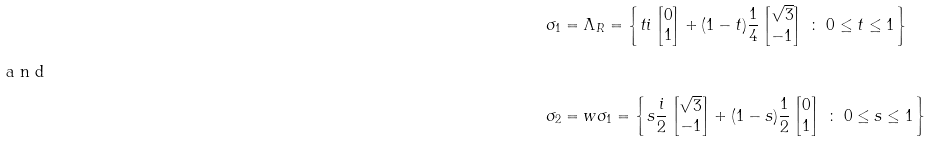Convert formula to latex. <formula><loc_0><loc_0><loc_500><loc_500>\sigma _ { 1 } & = \Lambda _ { R } = \left \{ t i \left [ \begin{matrix} 0 \\ 1 \end{matrix} \right ] + ( 1 - t ) \frac { 1 } { 4 } \left [ \begin{matrix} \sqrt { 3 } \\ - 1 \end{matrix} \right ] \ \colon \ 0 \leq t \leq 1 \right \} \\ \intertext { a n d } \sigma _ { 2 } & = w \sigma _ { 1 } = \left \{ s \frac { i } { 2 } \left [ \begin{matrix} \sqrt { 3 } \\ - 1 \end{matrix} \right ] + ( 1 - s ) \frac { 1 } { 2 } \left [ \begin{matrix} 0 \\ 1 \end{matrix} \right ] \ \colon \ 0 \leq s \leq 1 \right \}</formula> 